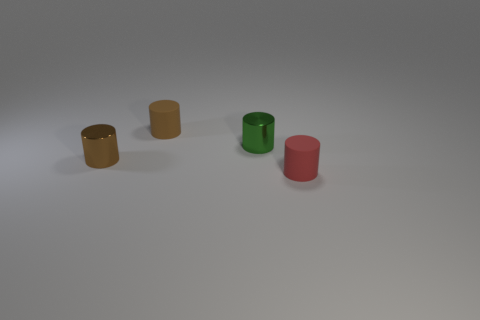There is a green thing that is the same size as the brown matte cylinder; what is its material?
Give a very brief answer. Metal. Does the matte object behind the small red rubber cylinder have the same color as the tiny metallic cylinder to the left of the brown rubber cylinder?
Keep it short and to the point. Yes. Is the material of the small green cylinder the same as the tiny red object?
Offer a terse response. No. Is the number of small brown matte cylinders behind the red rubber object greater than the number of brown rubber cylinders in front of the green object?
Make the answer very short. Yes. There is a tiny shiny object that is in front of the tiny green cylinder; what is its shape?
Give a very brief answer. Cylinder. Are there an equal number of green metallic cylinders that are on the left side of the green metal cylinder and cyan matte balls?
Keep it short and to the point. Yes. The brown rubber thing is what shape?
Keep it short and to the point. Cylinder. What size is the matte object in front of the small matte thing that is behind the cylinder in front of the brown metal cylinder?
Your response must be concise. Small. How many objects are either cylinders behind the tiny red cylinder or red rubber balls?
Your response must be concise. 3. What number of tiny rubber objects are in front of the small metal cylinder on the left side of the small green cylinder?
Your response must be concise. 1. 